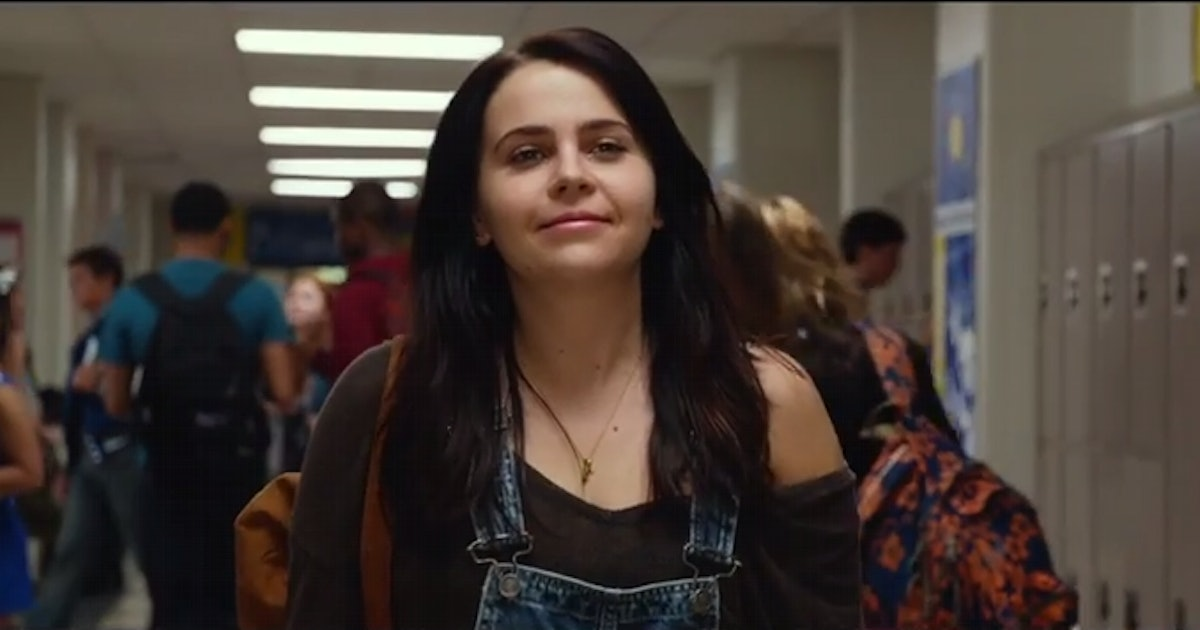If this scene had a soundtrack, what songs might be playing in the background? This scene could be set to a soundtrack that captures the essence of youth and the highs and lows of high school life. Songs like 'We Are Young' by Fun, 'Teenage Dream' by Katy Perry, and 'Ain't It Fun' by Paramore could perfectly encapsulate the energy and optimism of the hallway scene. The vibrant and upbeat tunes would accentuate the character’s feelings of confidence and excitement as she navigates through her day. 